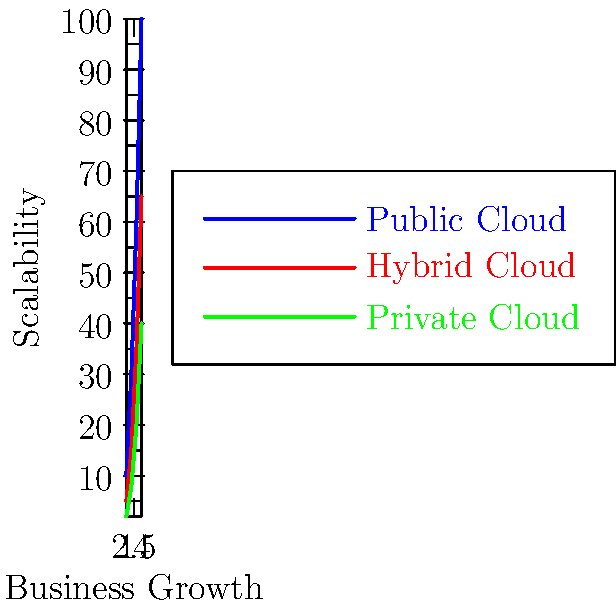As a customer excited about your favorite local business embracing digital transformation, you notice they're considering cloud storage options for scalability. Based on the graph showing different cloud storage solutions and their scalability as the business grows, which option offers the highest scalability potential for a rapidly expanding local business? To determine which cloud storage option offers the highest scalability potential, we need to analyze the graph:

1. The graph shows three different cloud storage options: Public Cloud (blue line), Hybrid Cloud (red line), and Private Cloud (green line).

2. The x-axis represents business growth, while the y-axis represents scalability.

3. We need to compare the slopes and end points of each line:

   a) Public Cloud (blue line): Has the steepest slope and reaches the highest point on the y-axis.
   b) Hybrid Cloud (red line): Has a moderate slope and reaches a middle point on the y-axis.
   c) Private Cloud (green line): Has the gentlest slope and reaches the lowest point on the y-axis.

4. A steeper slope indicates a faster rate of scalability as the business grows.

5. The highest end point on the y-axis represents the greatest overall scalability potential.

6. The Public Cloud option clearly demonstrates both the steepest slope and the highest end point.

Therefore, the Public Cloud option offers the highest scalability potential for a rapidly expanding local business.
Answer: Public Cloud 